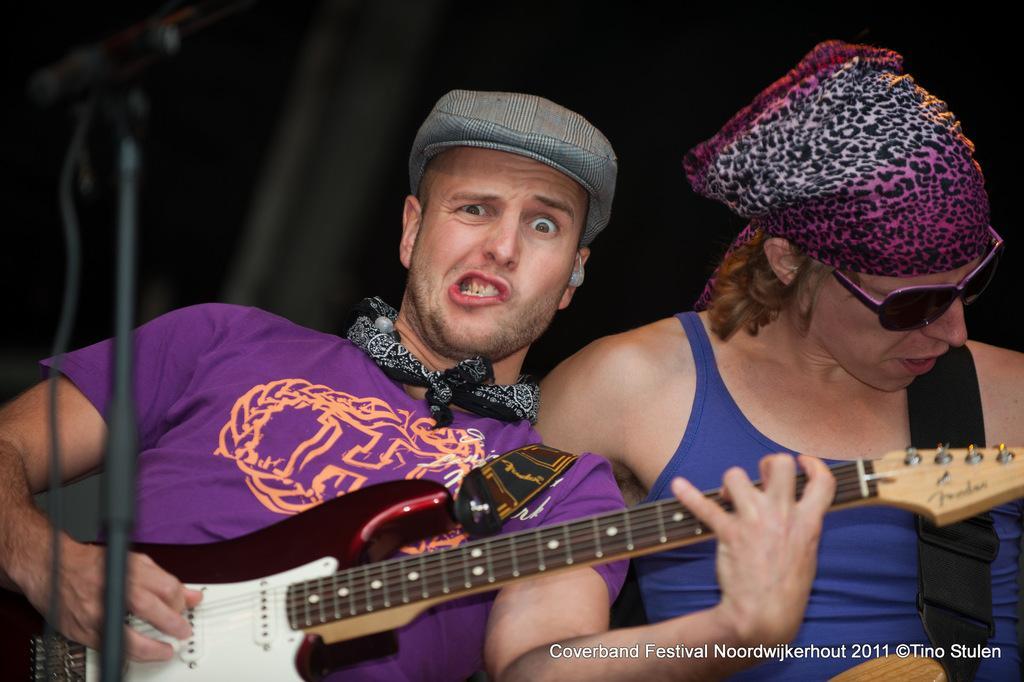How would you summarize this image in a sentence or two? there are two persons one person is playing guitar 